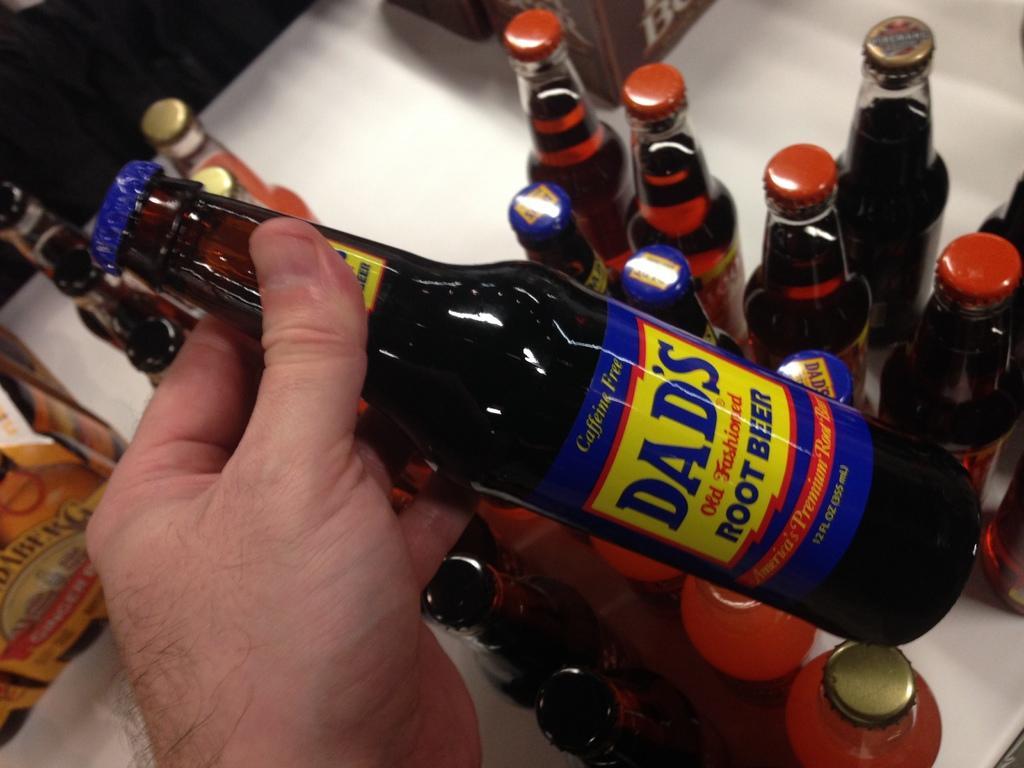How would you summarize this image in a sentence or two? In this image there are number of bottles. 